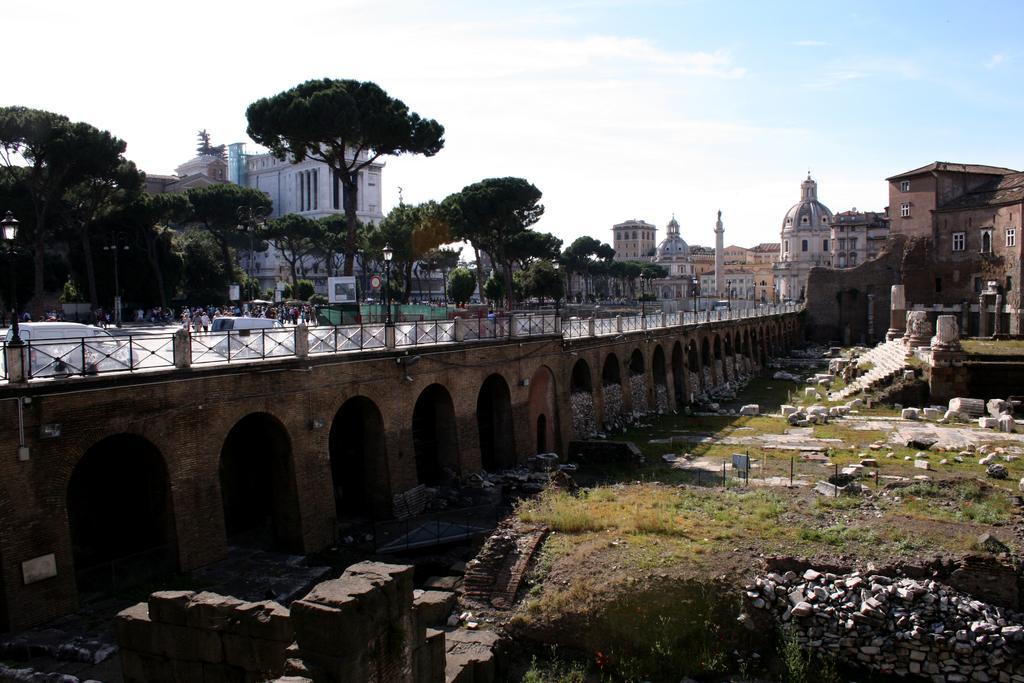Please provide a concise description of this image. In the image we can see there are buildings and vehicles on the road. Here we can see arch, stones, stairs, trees and the cloudy pale blue sky. There are people wearing clothes and the grass. 